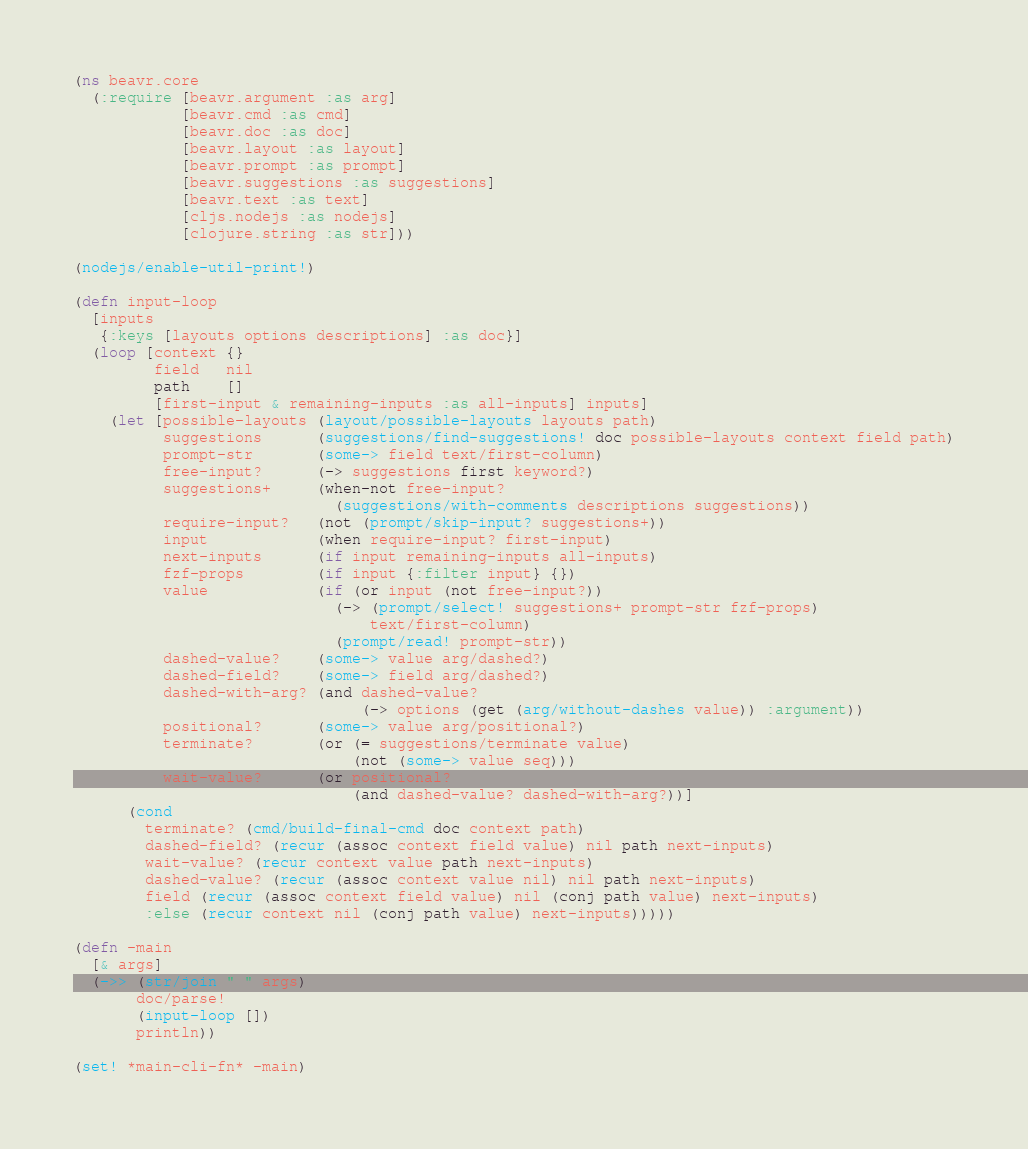Convert code to text. <code><loc_0><loc_0><loc_500><loc_500><_Clojure_>(ns beavr.core
  (:require [beavr.argument :as arg]
            [beavr.cmd :as cmd]
            [beavr.doc :as doc]
            [beavr.layout :as layout]
            [beavr.prompt :as prompt]
            [beavr.suggestions :as suggestions]
            [beavr.text :as text]
            [cljs.nodejs :as nodejs]
            [clojure.string :as str]))

(nodejs/enable-util-print!)

(defn input-loop
  [inputs
   {:keys [layouts options descriptions] :as doc}]
  (loop [context {}
         field   nil
         path    []
         [first-input & remaining-inputs :as all-inputs] inputs]
    (let [possible-layouts (layout/possible-layouts layouts path)
          suggestions      (suggestions/find-suggestions! doc possible-layouts context field path)
          prompt-str       (some-> field text/first-column)
          free-input?      (-> suggestions first keyword?)
          suggestions+     (when-not free-input?
                             (suggestions/with-comments descriptions suggestions))
          require-input?   (not (prompt/skip-input? suggestions+))
          input            (when require-input? first-input)
          next-inputs      (if input remaining-inputs all-inputs)
          fzf-props        (if input {:filter input} {})
          value            (if (or input (not free-input?))
                             (-> (prompt/select! suggestions+ prompt-str fzf-props)
                                 text/first-column)
                             (prompt/read! prompt-str))
          dashed-value?    (some-> value arg/dashed?)
          dashed-field?    (some-> field arg/dashed?)
          dashed-with-arg? (and dashed-value?
                                (-> options (get (arg/without-dashes value)) :argument))
          positional?      (some-> value arg/positional?)
          terminate?       (or (= suggestions/terminate value)
                               (not (some-> value seq)))
          wait-value?      (or positional?
                               (and dashed-value? dashed-with-arg?))]
      (cond
        terminate? (cmd/build-final-cmd doc context path)
        dashed-field? (recur (assoc context field value) nil path next-inputs)
        wait-value? (recur context value path next-inputs)
        dashed-value? (recur (assoc context value nil) nil path next-inputs)
        field (recur (assoc context field value) nil (conj path value) next-inputs)
        :else (recur context nil (conj path value) next-inputs)))))

(defn -main
  [& args]
  (->> (str/join " " args)
       doc/parse!
       (input-loop [])
       println))

(set! *main-cli-fn* -main)
</code> 